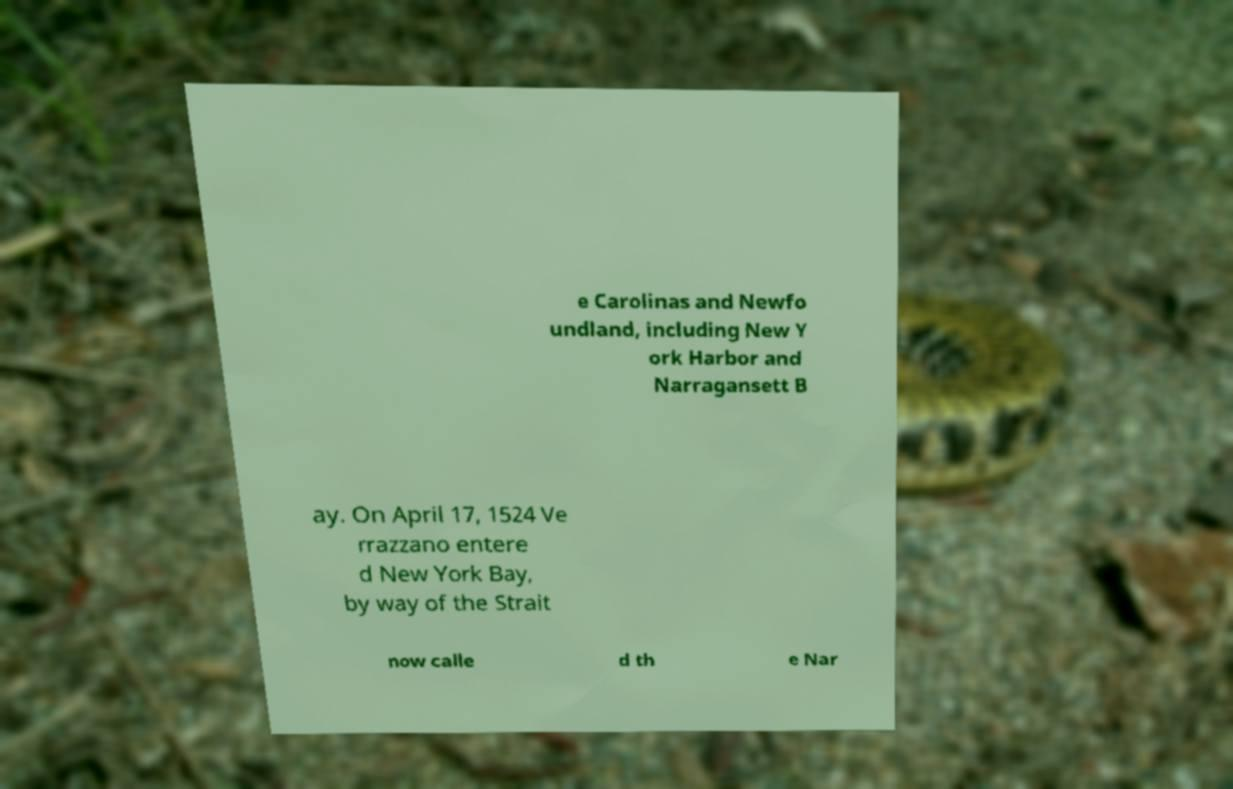I need the written content from this picture converted into text. Can you do that? e Carolinas and Newfo undland, including New Y ork Harbor and Narragansett B ay. On April 17, 1524 Ve rrazzano entere d New York Bay, by way of the Strait now calle d th e Nar 